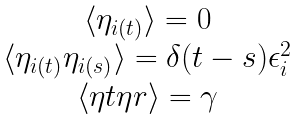<formula> <loc_0><loc_0><loc_500><loc_500>\begin{array} { c } \langle \eta _ { i ( t ) } \rangle = 0 \\ \langle \eta _ { i ( t ) } \eta _ { i ( s ) } \rangle = \delta ( t - s ) \epsilon ^ { 2 } _ { i } \\ \langle \eta t \eta r \rangle = \gamma \\ \end{array}</formula> 